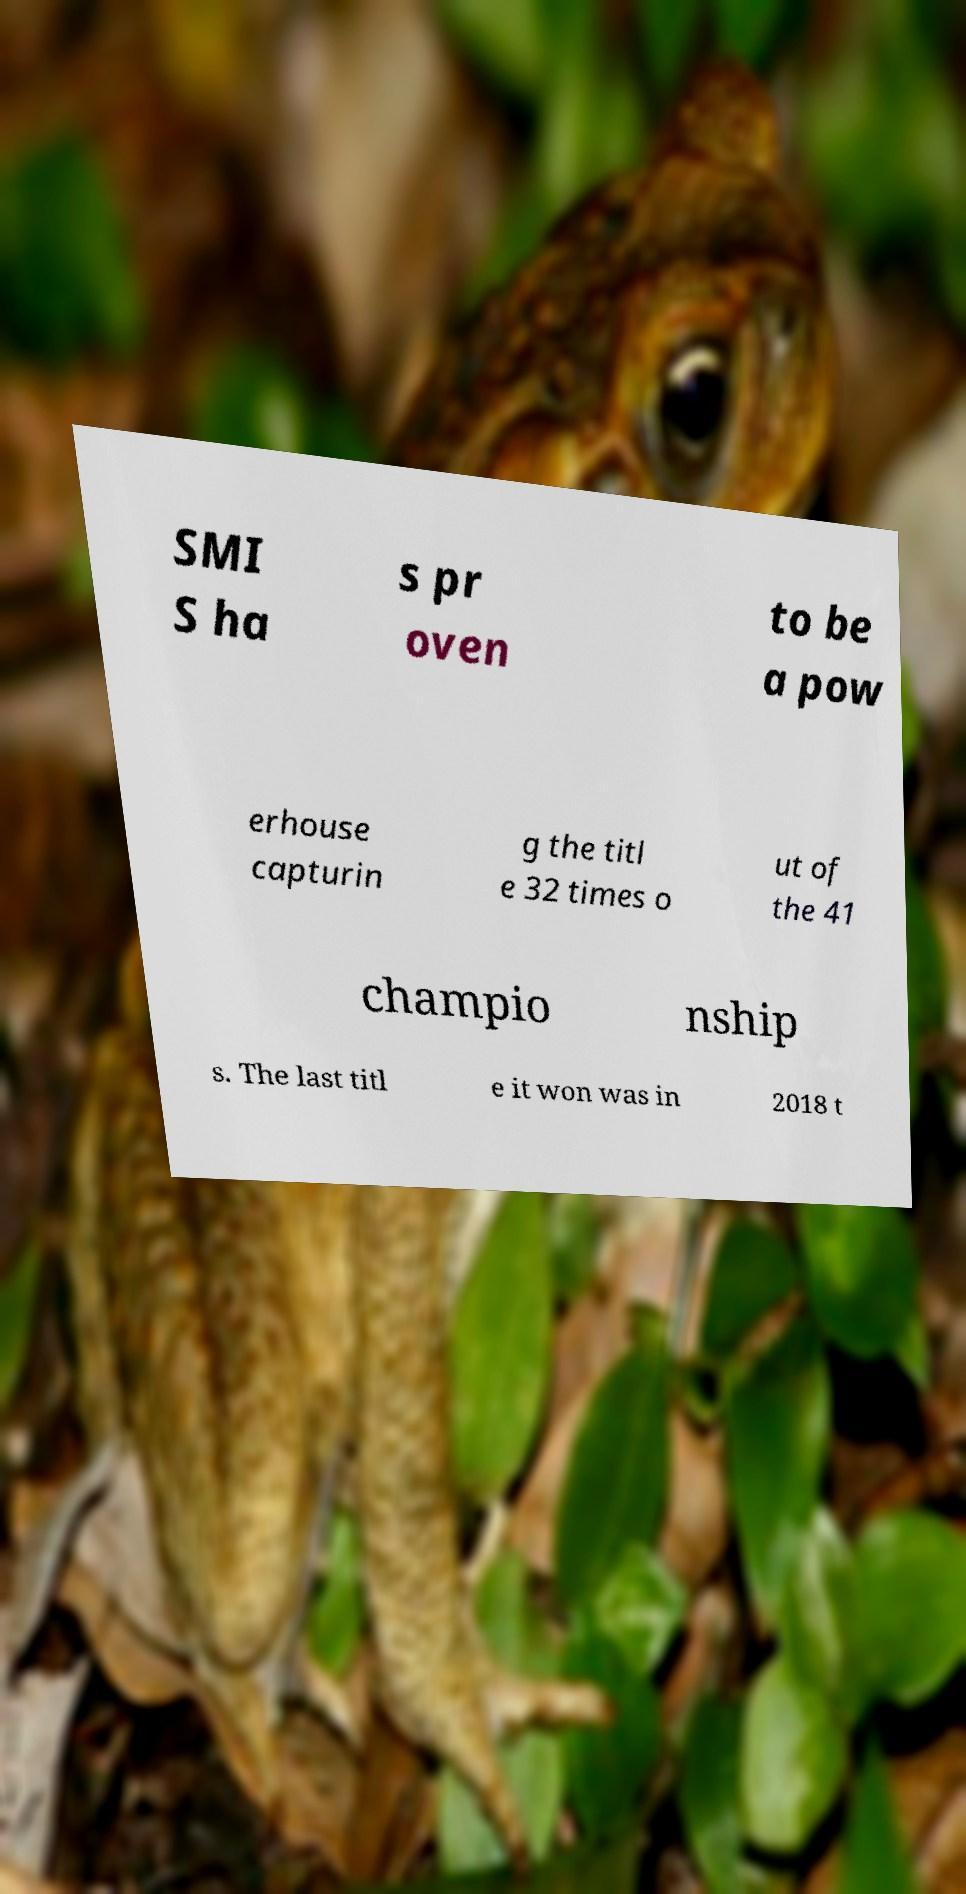Can you read and provide the text displayed in the image?This photo seems to have some interesting text. Can you extract and type it out for me? SMI S ha s pr oven to be a pow erhouse capturin g the titl e 32 times o ut of the 41 champio nship s. The last titl e it won was in 2018 t 